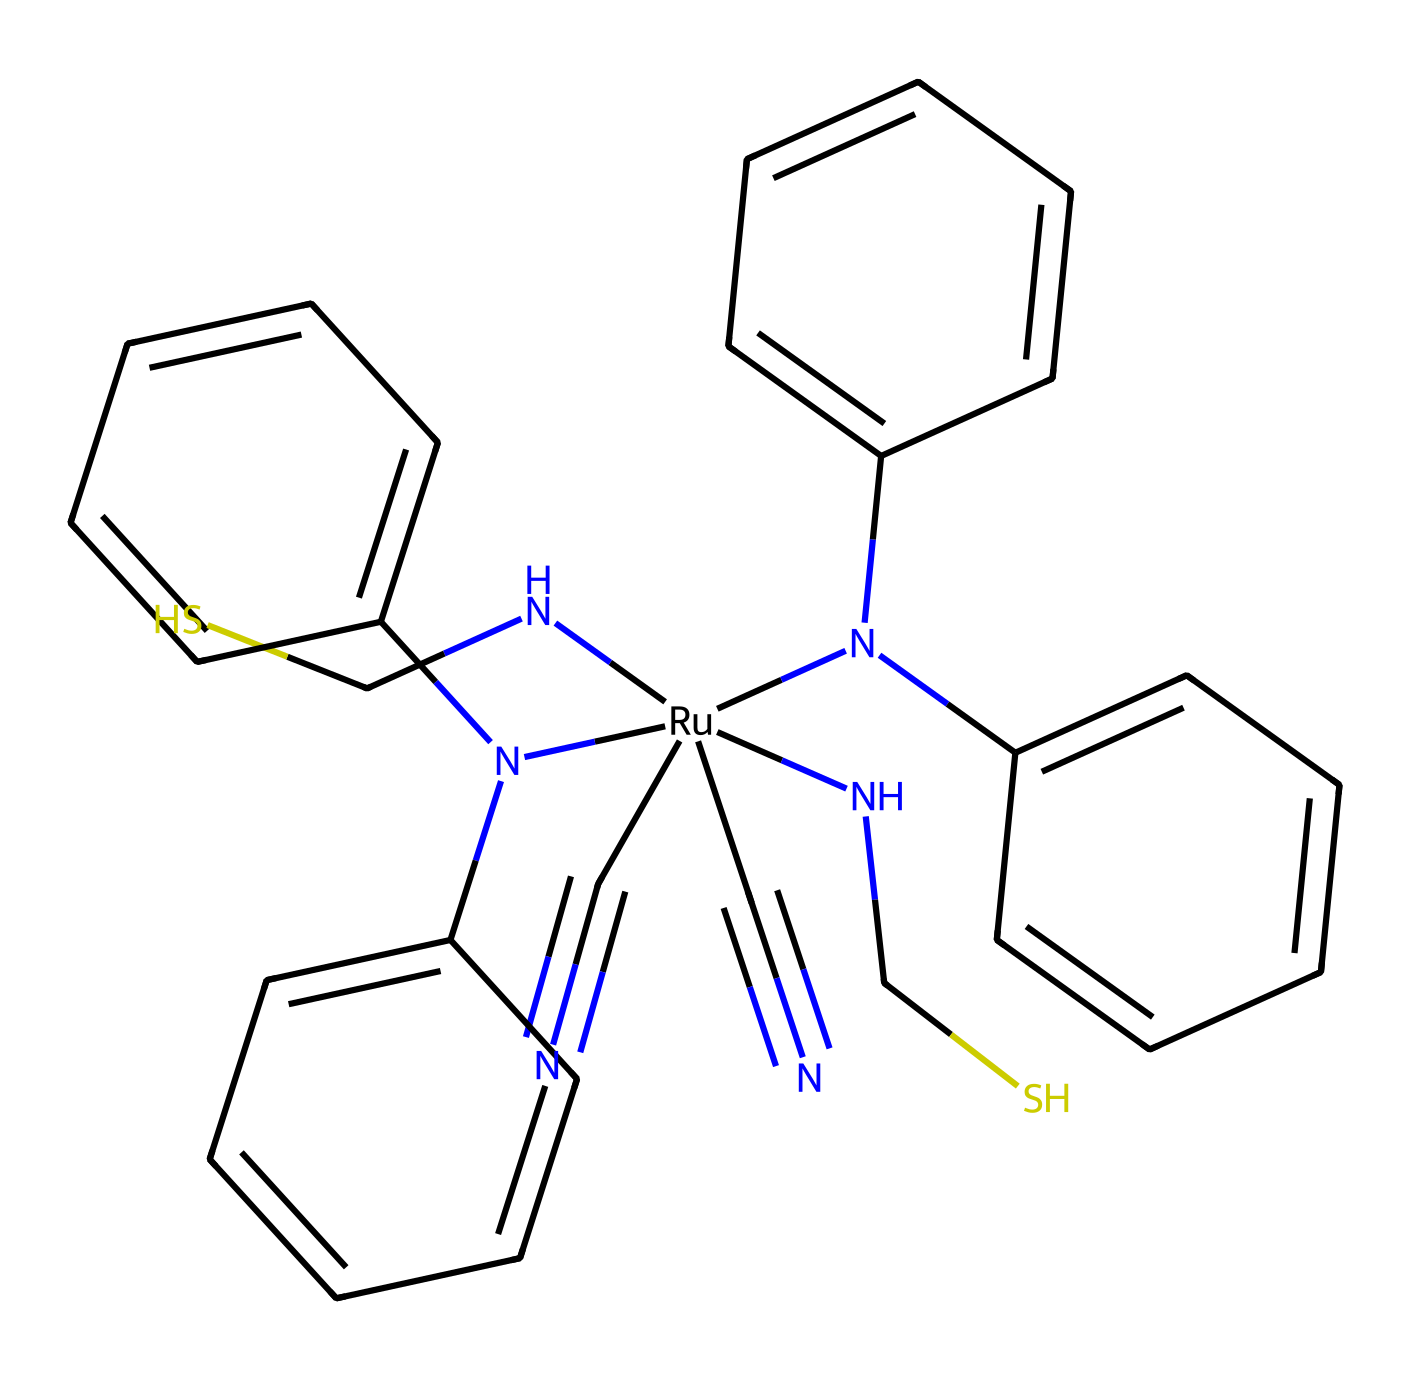What is the main metal in this dye? The chemical structure contains the atom indicated as [Ru], which represents ruthenium. This signifies that ruthenium is the central metal.
Answer: ruthenium How many nitrogen atoms are present? By examining the structure, we can count the nitrogen atoms that are represented by the 'N' symbols. There are four 'N' in the structure, indicating that there are four nitrogen atoms present.
Answer: four What is the functional group present that indicates it can donate electrons? The presence of the cyanide groups (C#N) in the structure denotes that it has electron-donating functional groups. These groups can participate in electron transfer processes.
Answer: cyanide What is the total number of aromatic rings present in this chemical? Upon analyzing the structure, there are two distinct pairs of phenyl groups (attached to the nitrogen atoms), resulting in two aromatic rings in the compound.
Answer: two Which part of this chemical indicates its photoreactive properties? The inclusion of the ruthenium center along with the cyano groups suggests its role in light absorption and subsequent electron transfer, which are critical for photochemistry.
Answer: ruthenium and cyano groups How many sulfur atoms are present in this structure? The structure depicts the presence of two 'S' symbols, indicating that there are two sulfur atoms in the compound attached via 'NCS' groups.
Answer: two 